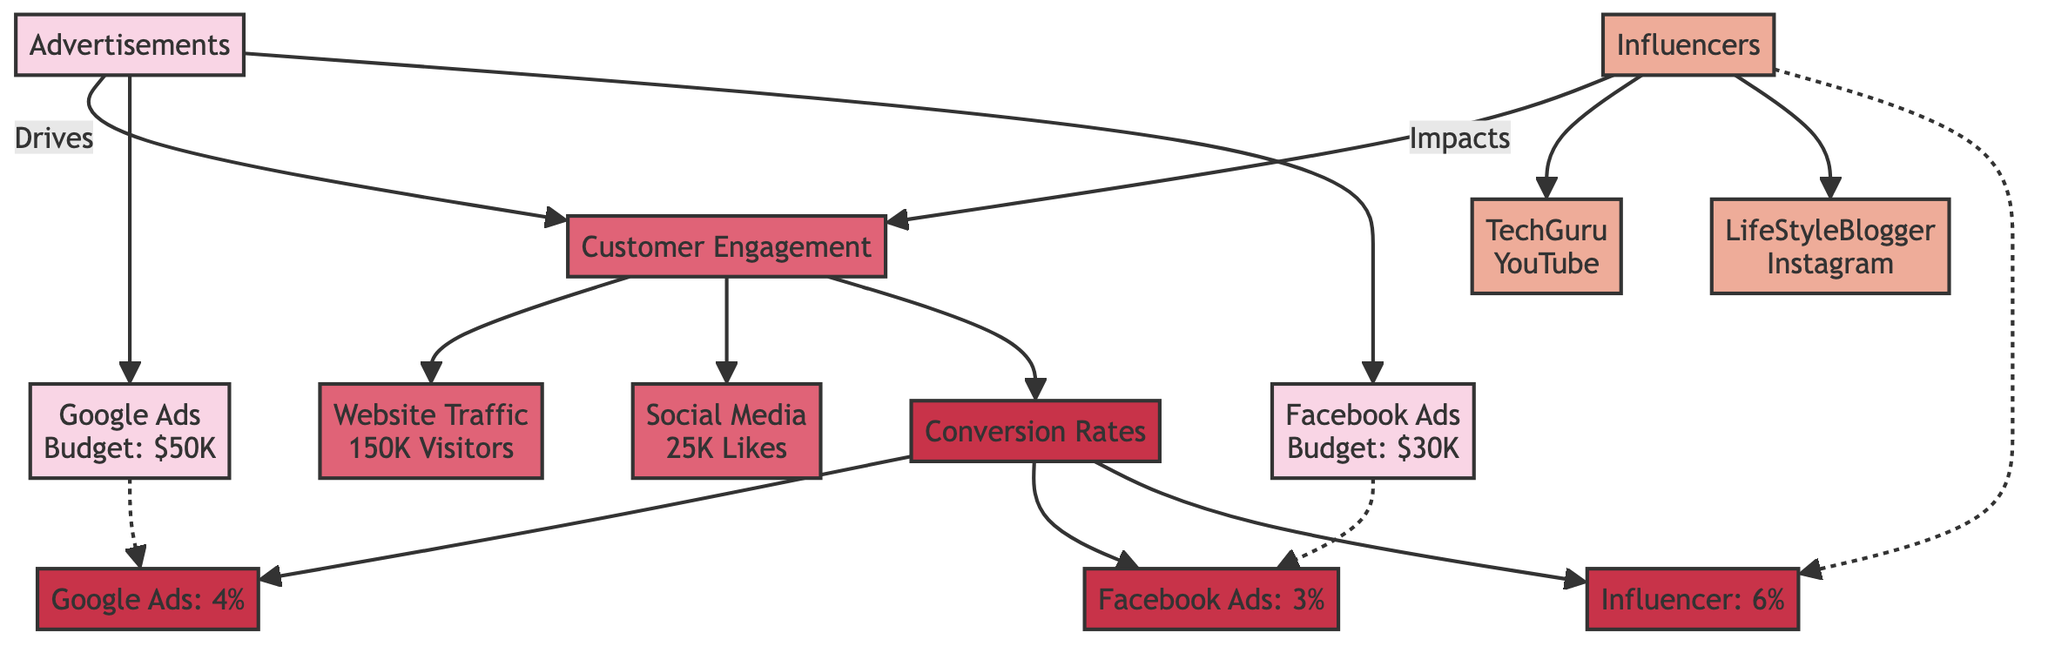What is the budget for the Google Ads campaign? The budget for the Google Ads campaign is stated on the node labeled "Google Ads" in the diagram, which indicates a budget of $50K.
Answer: $50K How many unique visitors does the website traffic have? The number of unique visitors for website traffic is shown in the node labeled "Website Traffic" which indicates 150K visitors.
Answer: 150K Which influencer has a higher engagement rate? To determine which influencer has a higher engagement rate, we compare the engagement rates shown in the nodes for "TechGuru" (0.05) and "LifeStyleBlogger" (0.08). Since 0.08 is greater than 0.05, "LifeStyleBlogger" has a higher engagement rate.
Answer: LifeStyleBlogger What is the purchase conversion rate for Facebook Ads? The conversion rate for Facebook Ads can be found in the node labeled "Facebook Ads" within the Conversion Rates section, which specifies a purchase conversion rate of 3%.
Answer: 3% Which advertisement has more potential budget? By comparing the budgets of the two advertisements, Google Ads has a budget of $50K while Facebook Ads has a budget of $30K. Therefore, Google Ads has more potential budget.
Answer: Google Ads Which type of engagement has 25,000 likes? The type of engagement that has 25,000 likes is specified in the node labeled "Social Media" within the Customer Engagement analytics.
Answer: Social Media What is the total number of advertisements listed in the diagram? There are two advertisements listed in the diagram: "Google Ads" and "Facebook Ads." Therefore, the total number is 2.
Answer: 2 How does influencer marketing impact conversion rates? To understand how influencer marketing impacts conversion rates, we observe that it has a purchase conversion rate of 6% as shown in the Conversion Rates section. Thus, influencer marketing positively influences conversion rates.
Answer: 6% What is the bounce rate associated with website traffic? The bounce rate can be found under the node labeled "Website Traffic," which specifies a bounce rate of 0.45.
Answer: 0.45 